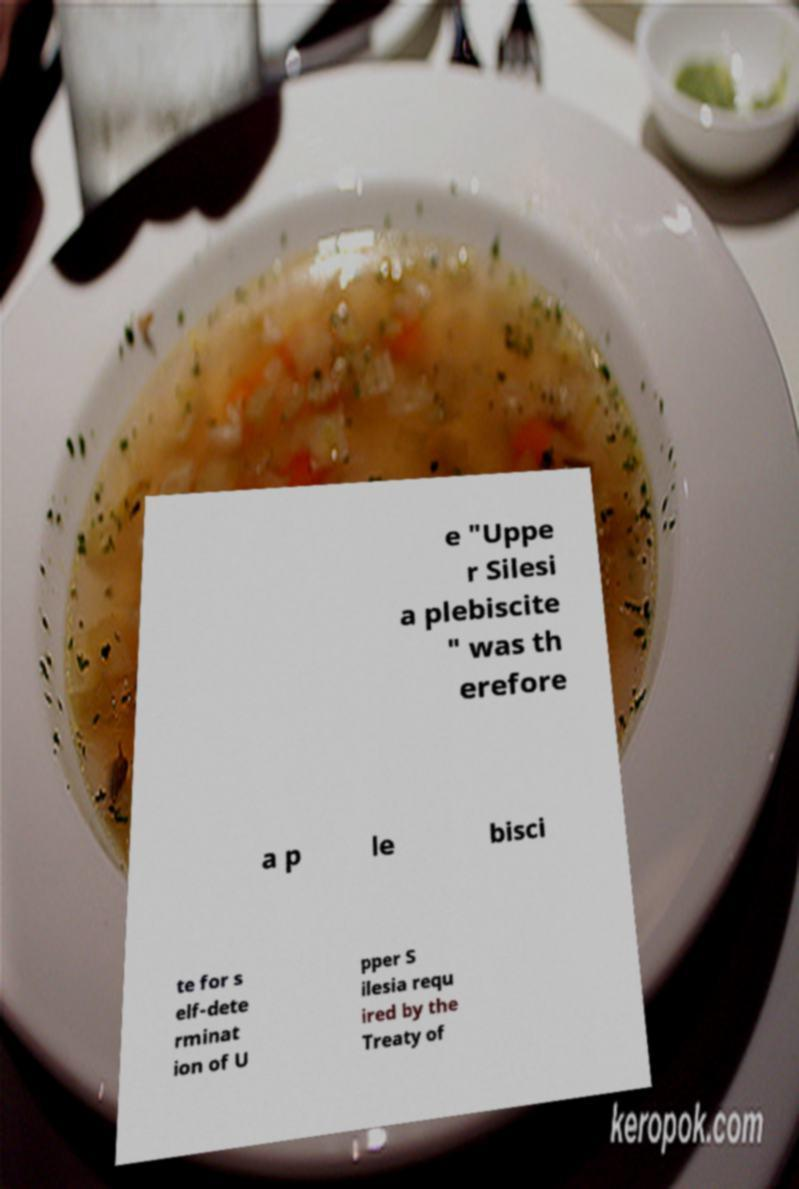I need the written content from this picture converted into text. Can you do that? e "Uppe r Silesi a plebiscite " was th erefore a p le bisci te for s elf-dete rminat ion of U pper S ilesia requ ired by the Treaty of 